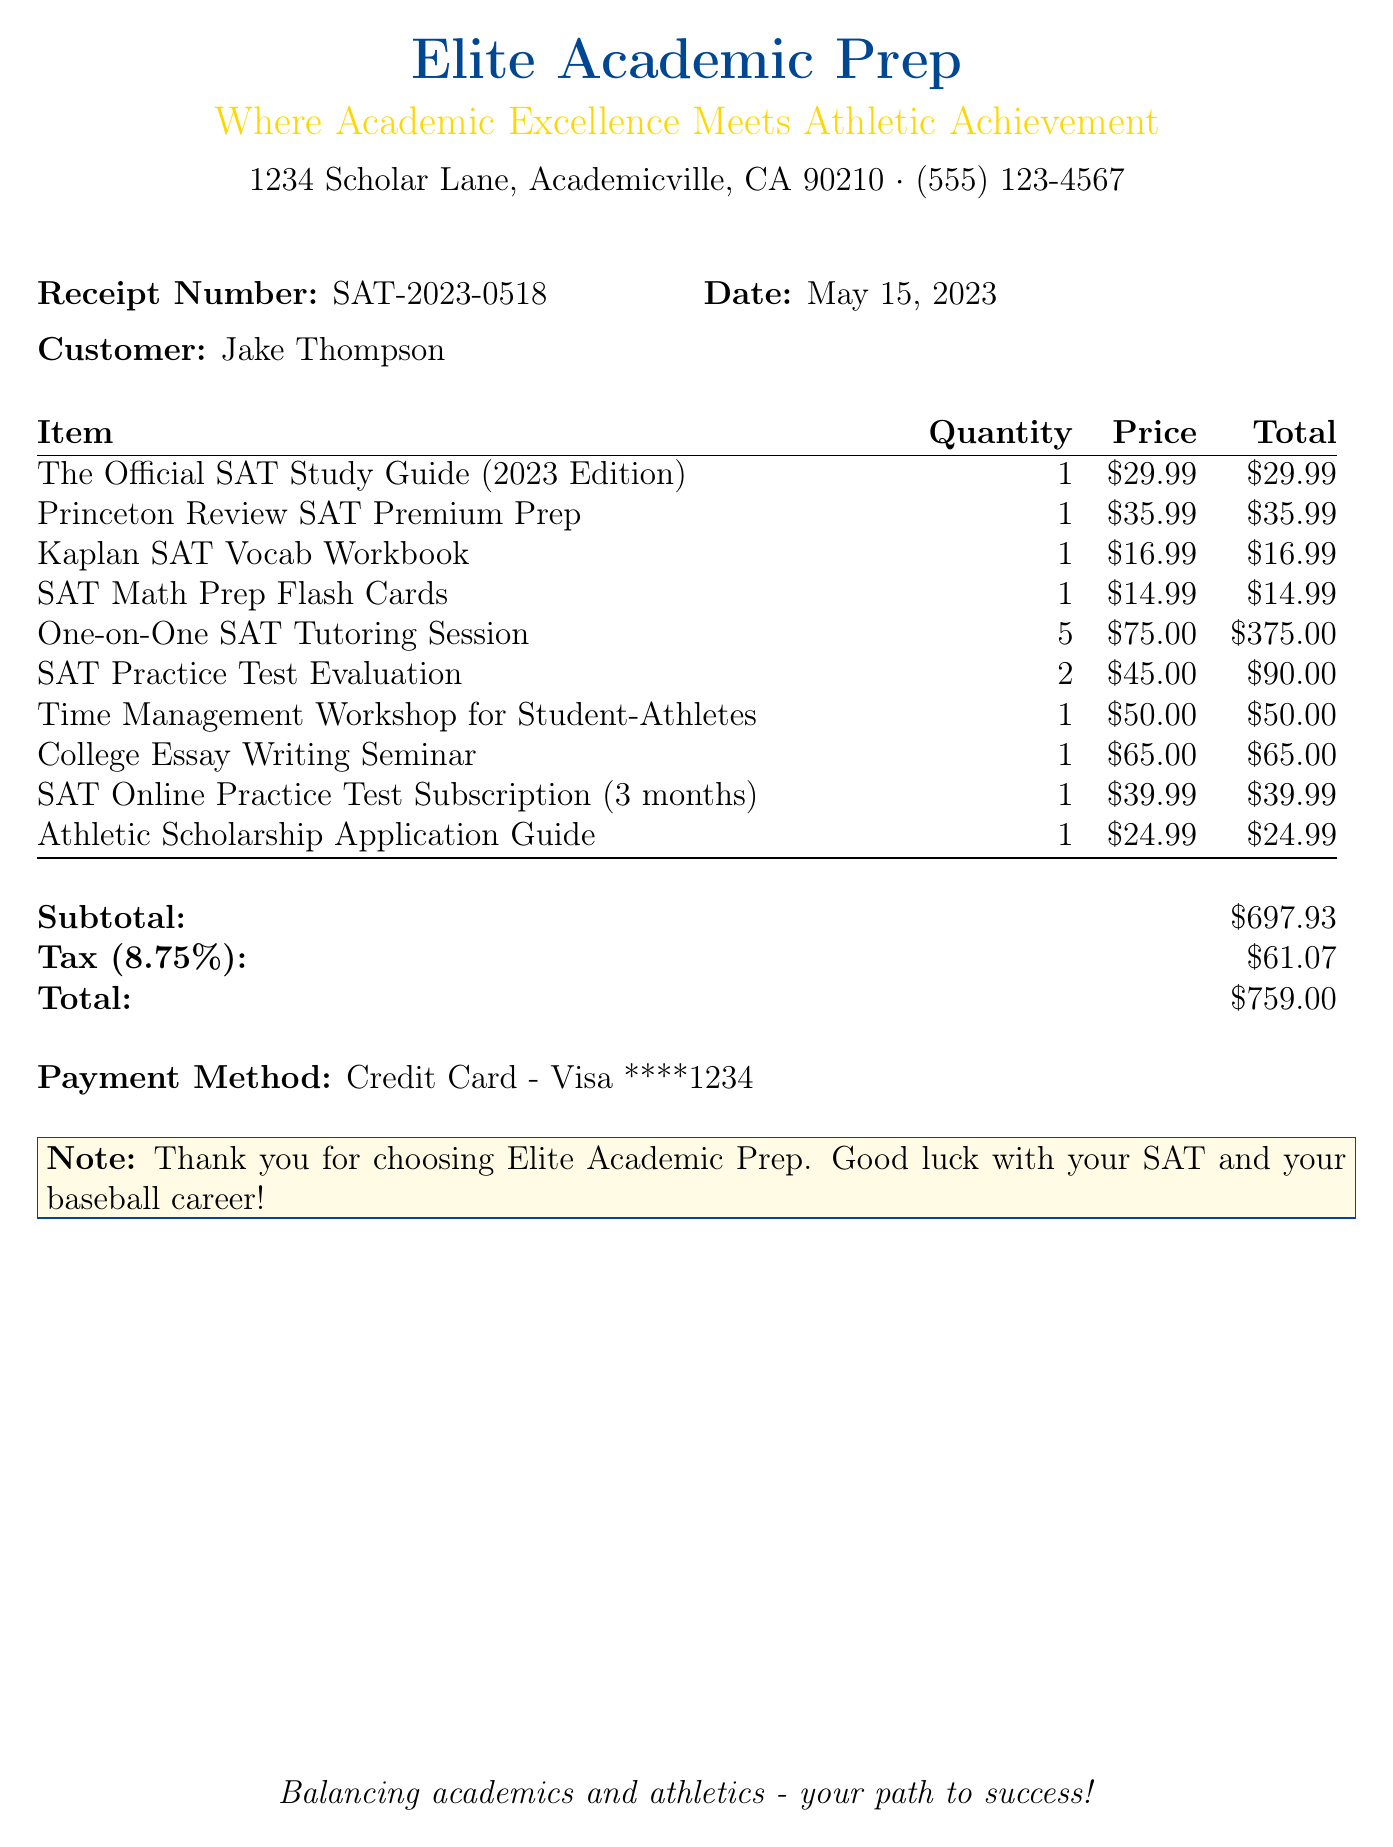What is the business name? The business name is listed at the top of the document.
Answer: Elite Academic Prep What is the subtotal amount? The subtotal amount is specified in the summary section of the document.
Answer: $697.93 How many one-on-one SAT tutoring sessions were purchased? The quantity of the one-on-one SAT tutoring sessions is indicated in the item list.
Answer: 5 What is the total amount due? The total amount is provided at the end of the receipt summary.
Answer: $759.00 What is the phone number of the business? The phone number is listed below the business name at the top of the document.
Answer: (555) 123-4567 How much was spent on SAT Practice Test Evaluations? The total cost for SAT Practice Test Evaluations can be calculated from the quantity and price provided.
Answer: $90.00 What is the tax rate applied? The tax rate is mentioned in the summary section of the document.
Answer: 8.75% What is the payment method used? The payment method is stated towards the end of the receipt.
Answer: Credit Card - Visa ****1234 What note is included in the receipt? The note is highlighted in a separate box towards the end of the document.
Answer: Thank you for choosing Elite Academic Prep. Good luck with your SAT and your baseball career! 